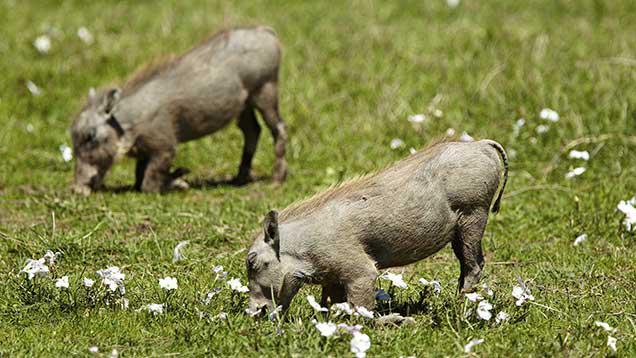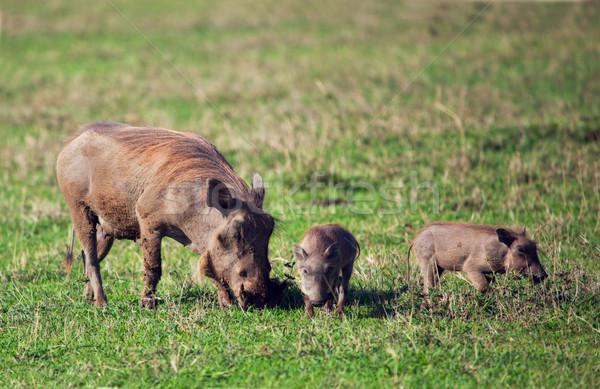The first image is the image on the left, the second image is the image on the right. Evaluate the accuracy of this statement regarding the images: "One of the images contains only one boar.". Is it true? Answer yes or no. No. 